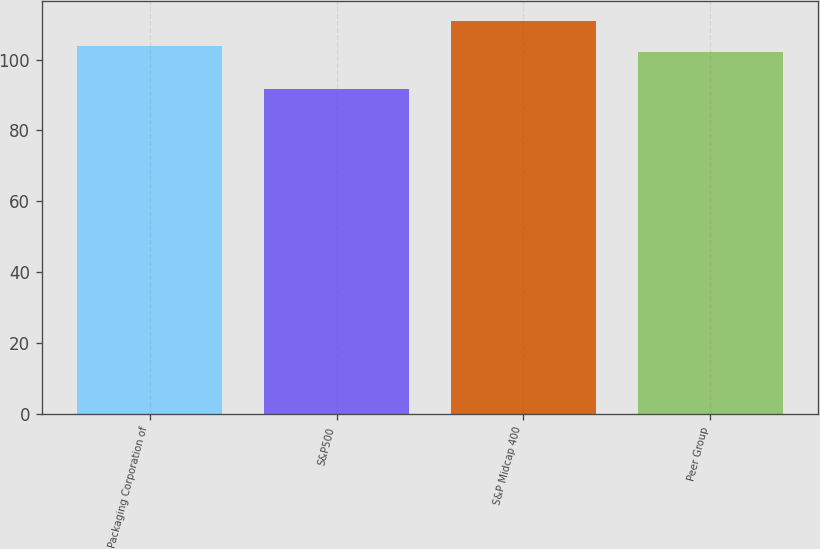Convert chart to OTSL. <chart><loc_0><loc_0><loc_500><loc_500><bar_chart><fcel>Packaging Corporation of<fcel>S&P500<fcel>S&P Midcap 400<fcel>Peer Group<nl><fcel>103.95<fcel>91.67<fcel>110.94<fcel>102.02<nl></chart> 